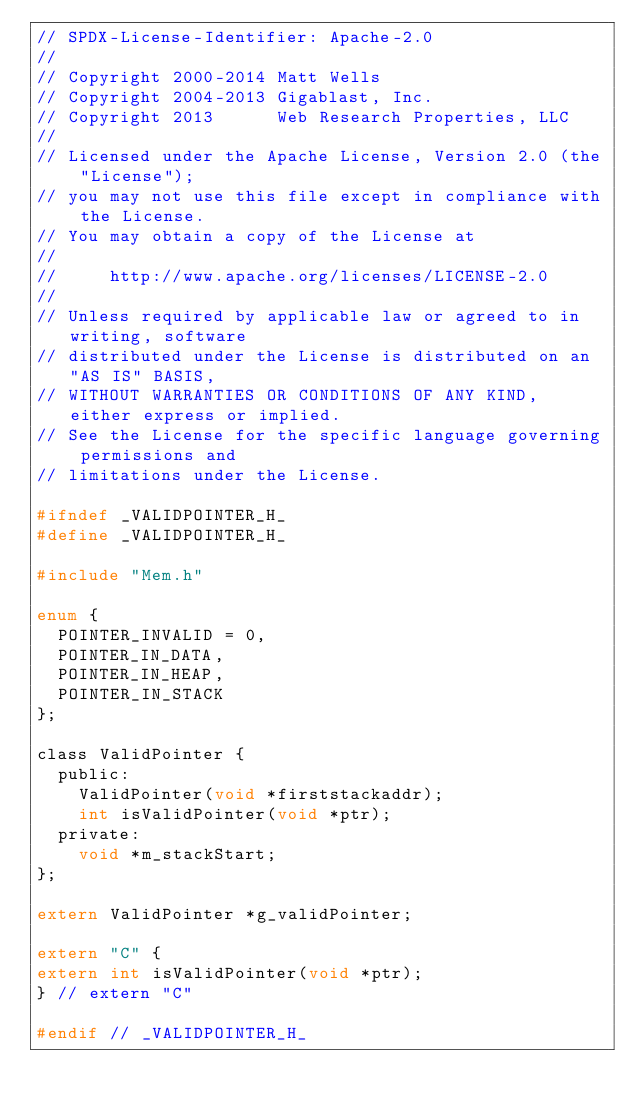<code> <loc_0><loc_0><loc_500><loc_500><_C_>// SPDX-License-Identifier: Apache-2.0
//
// Copyright 2000-2014 Matt Wells
// Copyright 2004-2013 Gigablast, Inc.
// Copyright 2013      Web Research Properties, LLC
//
// Licensed under the Apache License, Version 2.0 (the "License");
// you may not use this file except in compliance with the License.
// You may obtain a copy of the License at
//
//     http://www.apache.org/licenses/LICENSE-2.0
//
// Unless required by applicable law or agreed to in writing, software
// distributed under the License is distributed on an "AS IS" BASIS,
// WITHOUT WARRANTIES OR CONDITIONS OF ANY KIND, either express or implied.
// See the License for the specific language governing permissions and
// limitations under the License.

#ifndef _VALIDPOINTER_H_
#define _VALIDPOINTER_H_

#include "Mem.h"

enum {
	POINTER_INVALID = 0,
	POINTER_IN_DATA,
	POINTER_IN_HEAP,
	POINTER_IN_STACK
};

class ValidPointer {
	public:
		ValidPointer(void *firststackaddr);
		int isValidPointer(void *ptr);
	private:
		void *m_stackStart;
};

extern ValidPointer *g_validPointer;

extern "C" {
extern int isValidPointer(void *ptr);
} // extern "C"

#endif // _VALIDPOINTER_H_

</code> 